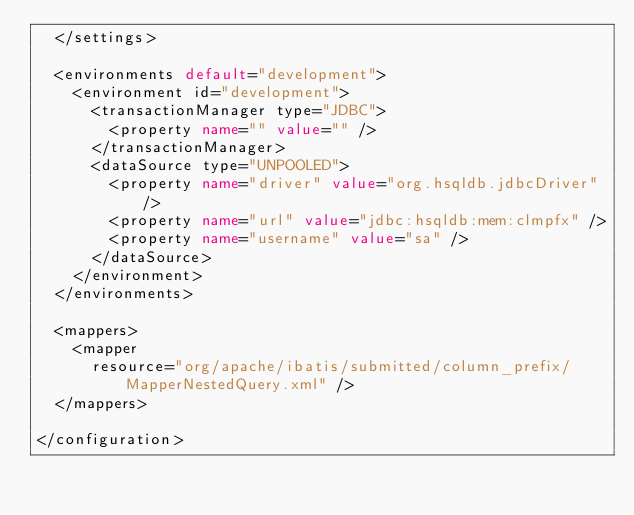Convert code to text. <code><loc_0><loc_0><loc_500><loc_500><_XML_>  </settings>

  <environments default="development">
    <environment id="development">
      <transactionManager type="JDBC">
        <property name="" value="" />
      </transactionManager>
      <dataSource type="UNPOOLED">
        <property name="driver" value="org.hsqldb.jdbcDriver" />
        <property name="url" value="jdbc:hsqldb:mem:clmpfx" />
        <property name="username" value="sa" />
      </dataSource>
    </environment>
  </environments>

  <mappers>
    <mapper
      resource="org/apache/ibatis/submitted/column_prefix/MapperNestedQuery.xml" />
  </mappers>

</configuration>
</code> 